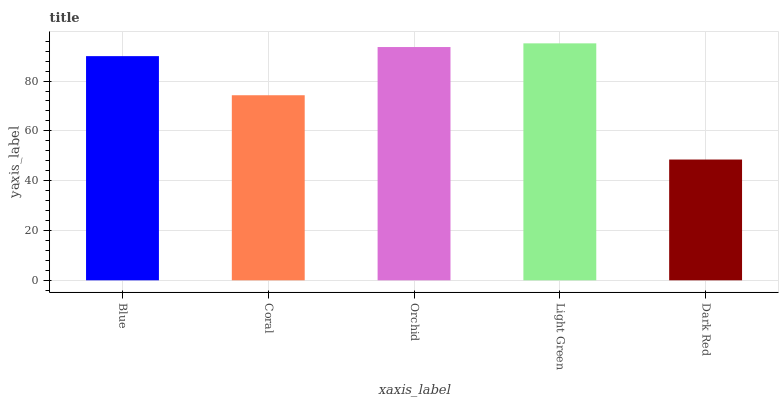Is Coral the minimum?
Answer yes or no. No. Is Coral the maximum?
Answer yes or no. No. Is Blue greater than Coral?
Answer yes or no. Yes. Is Coral less than Blue?
Answer yes or no. Yes. Is Coral greater than Blue?
Answer yes or no. No. Is Blue less than Coral?
Answer yes or no. No. Is Blue the high median?
Answer yes or no. Yes. Is Blue the low median?
Answer yes or no. Yes. Is Orchid the high median?
Answer yes or no. No. Is Coral the low median?
Answer yes or no. No. 